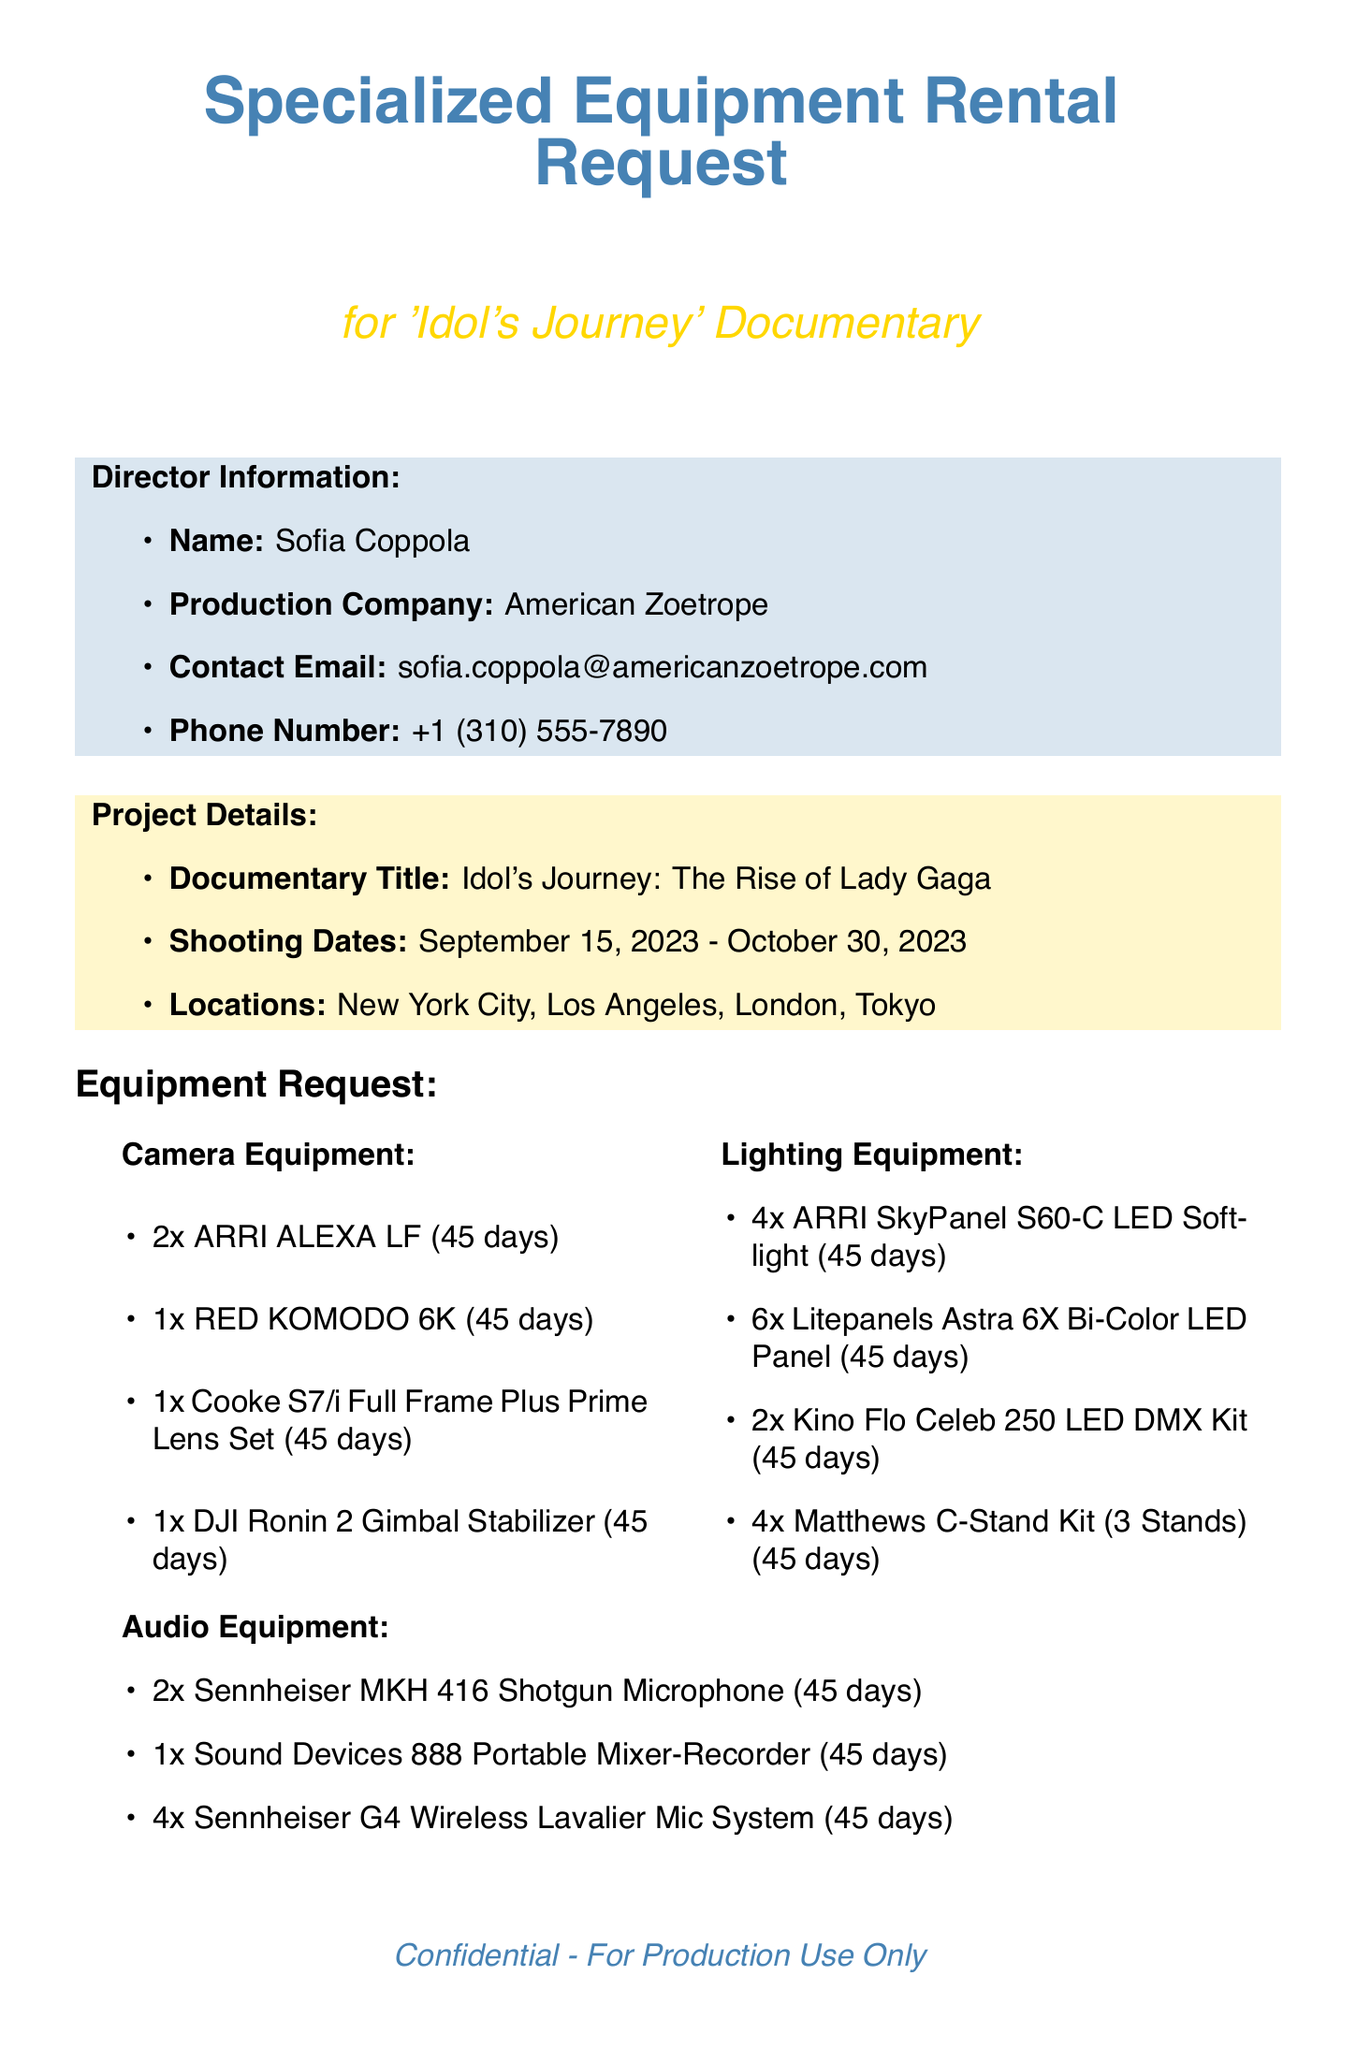What is the documentary title? The title of the documentary is stated in the project details section of the document.
Answer: Idol's Journey: The Rise of Lady Gaga Who is the director? The director's name is provided in the director information section of the document.
Answer: Sofia Coppola What is the total budget for equipment rental? The total budget is specified in the budget allocation section of the document.
Answer: $75,000 How many ARRI ALEXA LF cameras are requested? The quantity of ARRI ALEXA LF cameras is listed under the camera equipment section.
Answer: 2 What cities are mentioned as filming locations? The filming locations are provided in the project details section.
Answer: New York City, Los Angeles, London, Tokyo What is a special requirement for the equipment? One of the special requirements relates to the insurance for the equipment, which is mentioned in the special requirements section.
Answer: All equipment must be insured for international travel How long is the rental duration for all requested equipment? The rental duration is mentioned repeatedly in the equipment sections of the document.
Answer: 45 days Which company is the preferred rental company? The preferred rental companies are listed in the rental company preferences section.
Answer: Panavision How many Sennheiser G4 Wireless Lavalier Mic Systems are requested? The quantity of Sennheiser G4 Wireless Lavalier Mic Systems is mentioned in the audio equipment section.
Answer: 4 